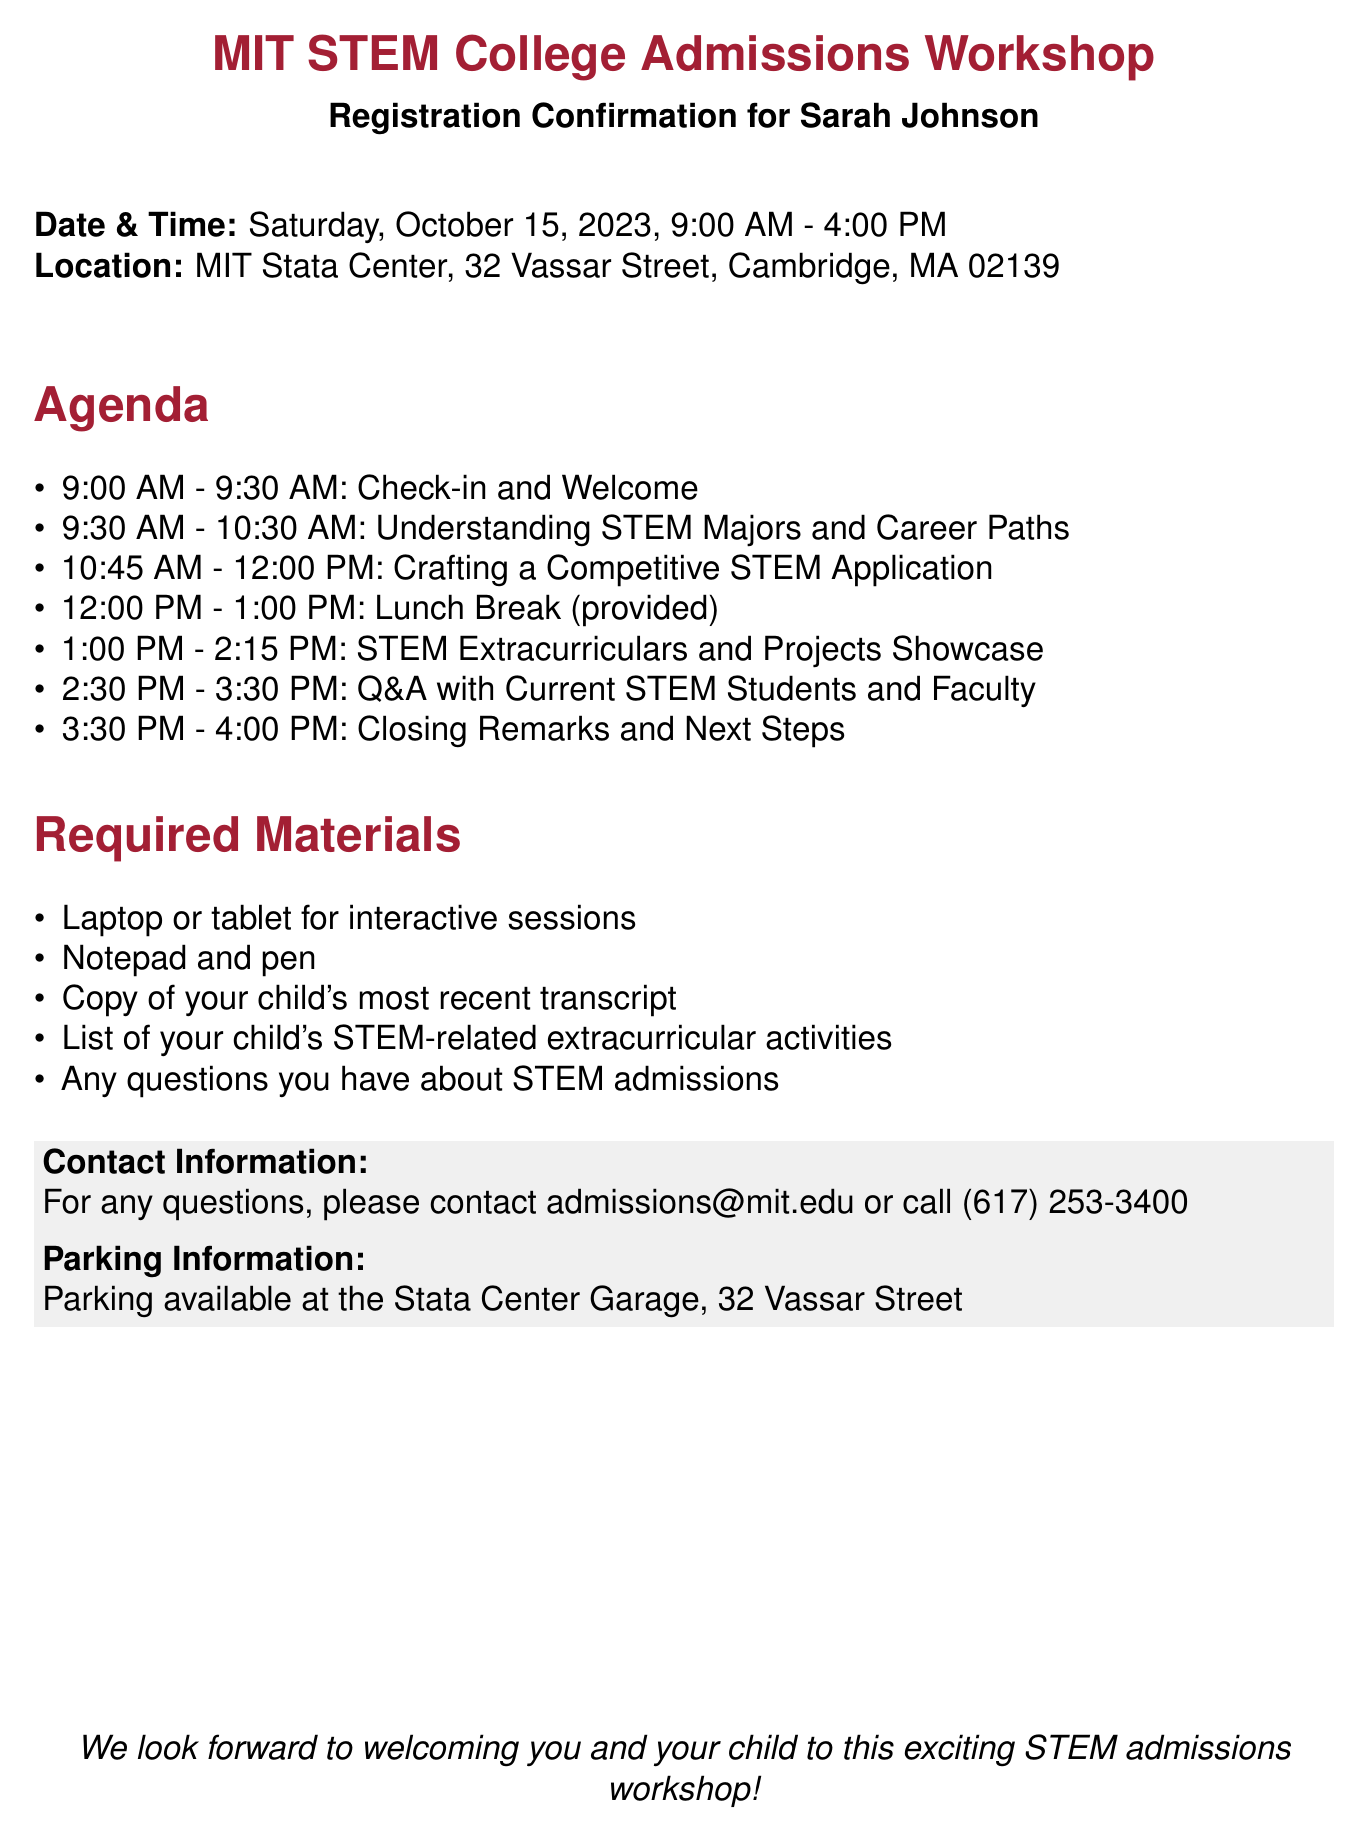What is the date of the workshop? The date of the workshop is explicitly mentioned in the document.
Answer: Saturday, October 15, 2023 What time does the workshop start? The starting time is specified in the event details within the document.
Answer: 9:00 AM Where is the workshop located? The location of the workshop is provided in the document under the location header.
Answer: MIT Stata Center, 32 Vassar Street, Cambridge, MA 02139 What is one of the required materials to bring? The required materials section lists items that participants need to bring to the workshop.
Answer: Laptop or tablet for interactive sessions Who can you contact for questions? The contact information section provides details for inquiries and assistance.
Answer: admissions@mit.edu What is one topic covered in the agenda? The agenda lists topics to be discussed during different times of the workshop.
Answer: Understanding STEM Majors and Career Paths How long is the lunch break? The lunch break duration is specified in the agenda section of the document.
Answer: 1 hour How many sessions are there before lunch? The agenda details the number of sessions scheduled before the lunch break.
Answer: 3 sessions What is the ending time of the workshop? The end time for the workshop is mentioned in the document details.
Answer: 4:00 PM 